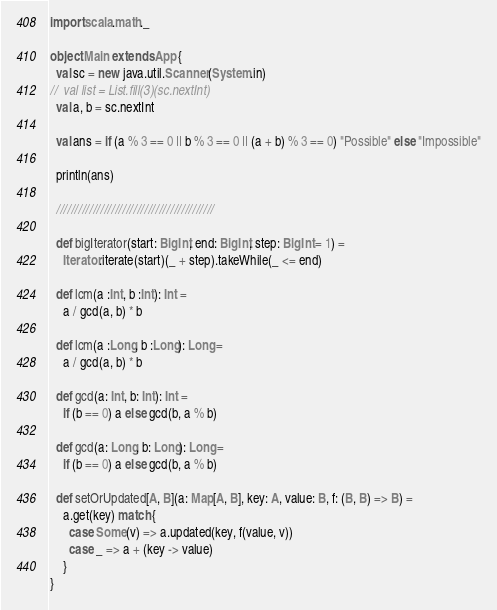<code> <loc_0><loc_0><loc_500><loc_500><_Scala_>import scala.math._

object Main extends App {
  val sc = new java.util.Scanner(System.in)
//  val list = List.fill(3)(sc.nextInt)
  val a, b = sc.nextInt

  val ans = if (a % 3 == 0 || b % 3 == 0 || (a + b) % 3 == 0) "Possible" else "Impossible"

  println(ans)

  ///////////////////////////////////////////

  def bigIterator(start: BigInt, end: BigInt, step: BigInt = 1) =
    Iterator.iterate(start)(_ + step).takeWhile(_ <= end)

  def lcm(a :Int, b :Int): Int =
    a / gcd(a, b) * b

  def lcm(a :Long, b :Long): Long =
    a / gcd(a, b) * b

  def gcd(a: Int, b: Int): Int =
    if (b == 0) a else gcd(b, a % b)

  def gcd(a: Long, b: Long): Long =
    if (b == 0) a else gcd(b, a % b)

  def setOrUpdated[A, B](a: Map[A, B], key: A, value: B, f: (B, B) => B) =
    a.get(key) match {
      case Some(v) => a.updated(key, f(value, v))
      case _ => a + (key -> value)
    }
}</code> 